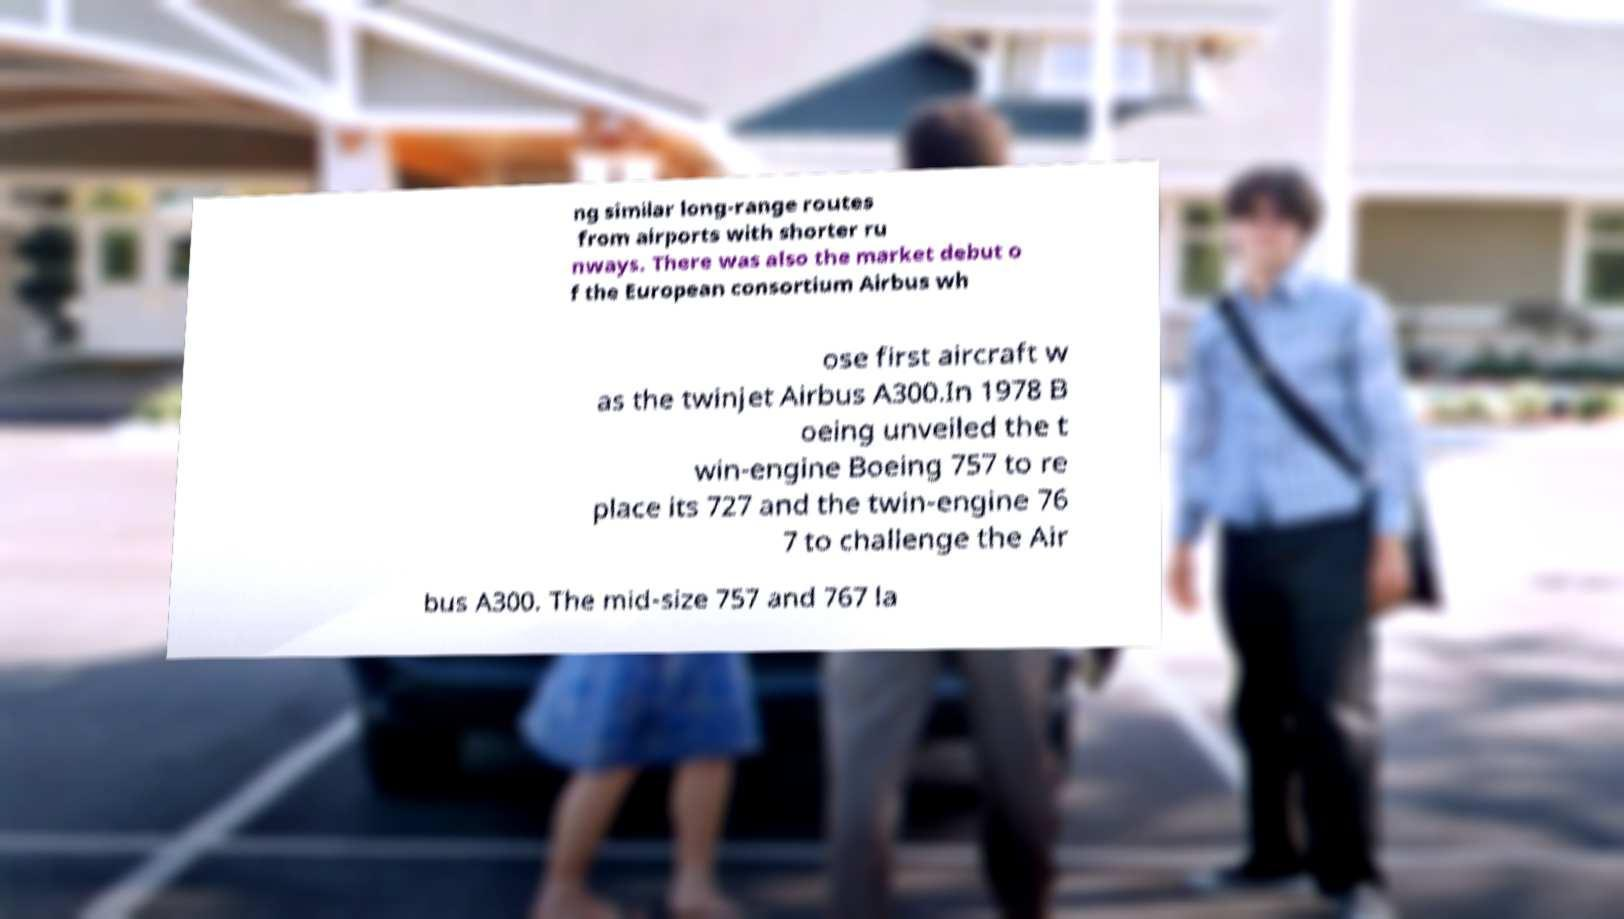There's text embedded in this image that I need extracted. Can you transcribe it verbatim? ng similar long-range routes from airports with shorter ru nways. There was also the market debut o f the European consortium Airbus wh ose first aircraft w as the twinjet Airbus A300.In 1978 B oeing unveiled the t win-engine Boeing 757 to re place its 727 and the twin-engine 76 7 to challenge the Air bus A300. The mid-size 757 and 767 la 